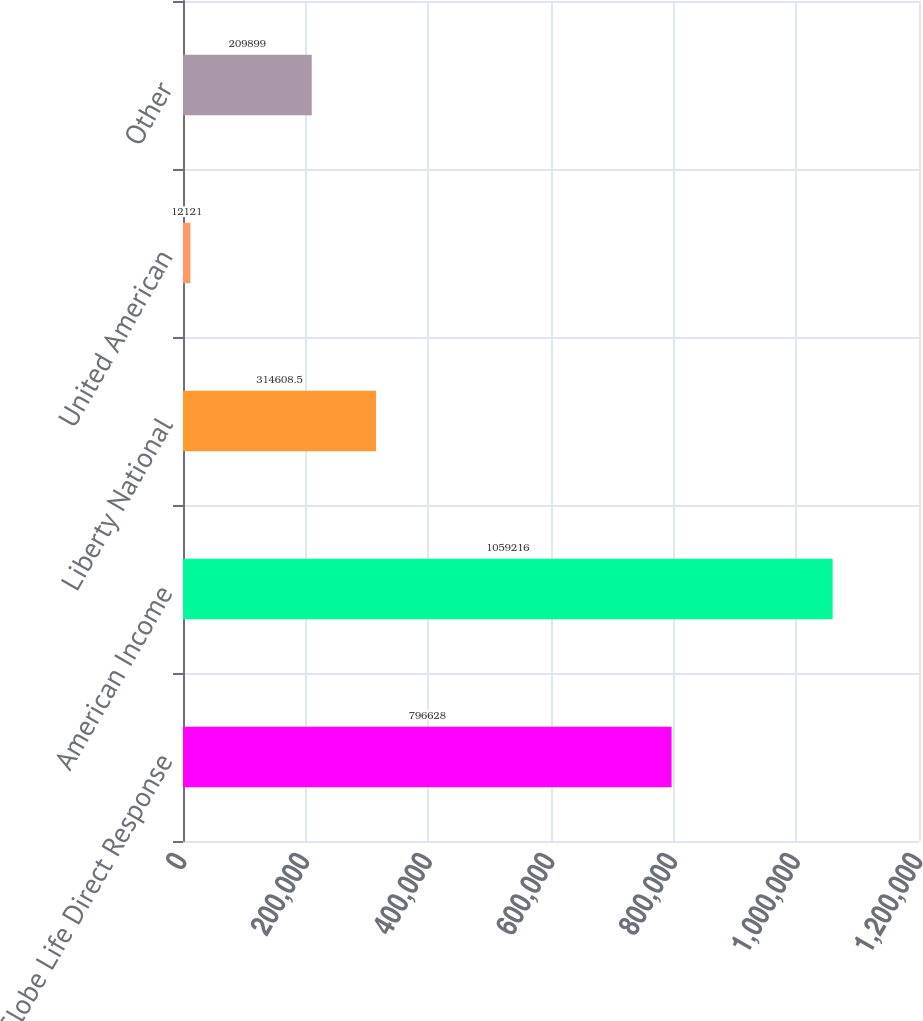Convert chart. <chart><loc_0><loc_0><loc_500><loc_500><bar_chart><fcel>Globe Life Direct Response<fcel>American Income<fcel>Liberty National<fcel>United American<fcel>Other<nl><fcel>796628<fcel>1.05922e+06<fcel>314608<fcel>12121<fcel>209899<nl></chart> 